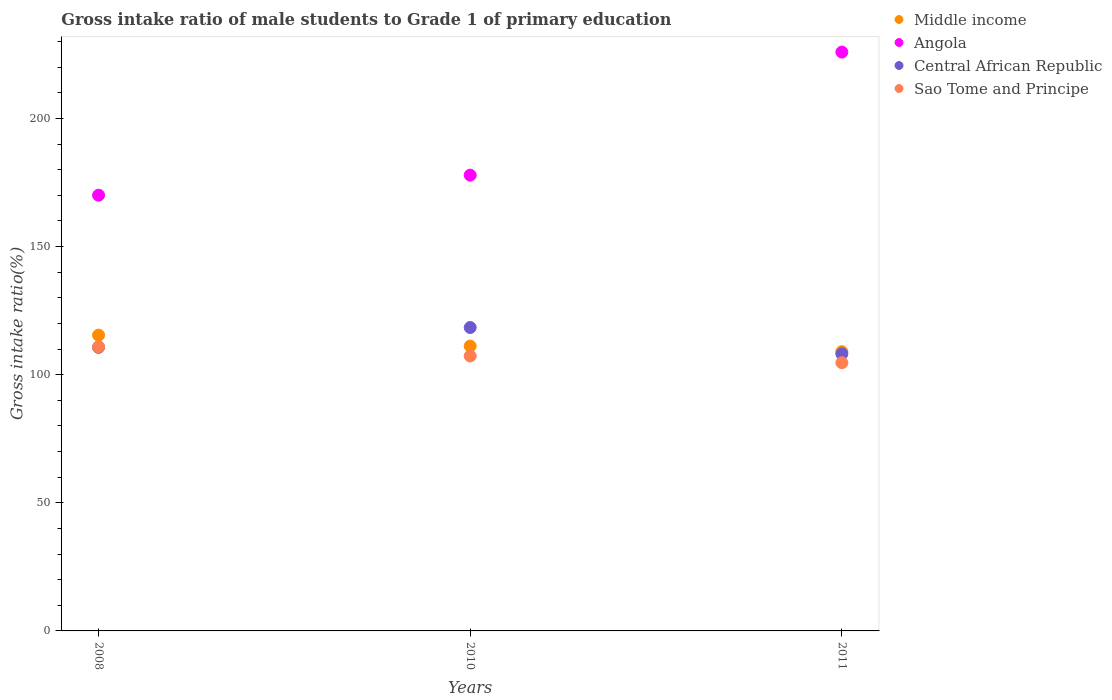How many different coloured dotlines are there?
Your answer should be compact. 4. What is the gross intake ratio in Angola in 2008?
Make the answer very short. 170.04. Across all years, what is the maximum gross intake ratio in Central African Republic?
Ensure brevity in your answer.  118.4. Across all years, what is the minimum gross intake ratio in Angola?
Your answer should be compact. 170.04. In which year was the gross intake ratio in Angola maximum?
Keep it short and to the point. 2011. In which year was the gross intake ratio in Central African Republic minimum?
Ensure brevity in your answer.  2011. What is the total gross intake ratio in Central African Republic in the graph?
Make the answer very short. 337.19. What is the difference between the gross intake ratio in Angola in 2010 and that in 2011?
Provide a succinct answer. -48.03. What is the difference between the gross intake ratio in Angola in 2008 and the gross intake ratio in Central African Republic in 2010?
Make the answer very short. 51.64. What is the average gross intake ratio in Sao Tome and Principe per year?
Offer a very short reply. 107.62. In the year 2011, what is the difference between the gross intake ratio in Middle income and gross intake ratio in Angola?
Provide a short and direct response. -116.92. What is the ratio of the gross intake ratio in Angola in 2008 to that in 2010?
Your answer should be very brief. 0.96. What is the difference between the highest and the second highest gross intake ratio in Middle income?
Offer a very short reply. 4.25. What is the difference between the highest and the lowest gross intake ratio in Central African Republic?
Offer a terse response. 10.28. In how many years, is the gross intake ratio in Angola greater than the average gross intake ratio in Angola taken over all years?
Make the answer very short. 1. Is the sum of the gross intake ratio in Sao Tome and Principe in 2008 and 2011 greater than the maximum gross intake ratio in Central African Republic across all years?
Ensure brevity in your answer.  Yes. Is it the case that in every year, the sum of the gross intake ratio in Sao Tome and Principe and gross intake ratio in Middle income  is greater than the gross intake ratio in Angola?
Make the answer very short. No. Does the gross intake ratio in Middle income monotonically increase over the years?
Your answer should be compact. No. Is the gross intake ratio in Central African Republic strictly less than the gross intake ratio in Sao Tome and Principe over the years?
Your response must be concise. No. How many dotlines are there?
Ensure brevity in your answer.  4. Does the graph contain grids?
Keep it short and to the point. No. Where does the legend appear in the graph?
Your answer should be very brief. Top right. How many legend labels are there?
Provide a succinct answer. 4. How are the legend labels stacked?
Provide a short and direct response. Vertical. What is the title of the graph?
Offer a terse response. Gross intake ratio of male students to Grade 1 of primary education. What is the label or title of the X-axis?
Your answer should be very brief. Years. What is the label or title of the Y-axis?
Provide a short and direct response. Gross intake ratio(%). What is the Gross intake ratio(%) of Middle income in 2008?
Offer a terse response. 115.42. What is the Gross intake ratio(%) of Angola in 2008?
Provide a succinct answer. 170.04. What is the Gross intake ratio(%) of Central African Republic in 2008?
Your answer should be compact. 110.66. What is the Gross intake ratio(%) in Sao Tome and Principe in 2008?
Give a very brief answer. 110.88. What is the Gross intake ratio(%) of Middle income in 2010?
Give a very brief answer. 111.17. What is the Gross intake ratio(%) in Angola in 2010?
Make the answer very short. 177.86. What is the Gross intake ratio(%) in Central African Republic in 2010?
Your response must be concise. 118.4. What is the Gross intake ratio(%) in Sao Tome and Principe in 2010?
Your answer should be very brief. 107.3. What is the Gross intake ratio(%) in Middle income in 2011?
Your answer should be compact. 108.97. What is the Gross intake ratio(%) of Angola in 2011?
Provide a succinct answer. 225.89. What is the Gross intake ratio(%) of Central African Republic in 2011?
Provide a short and direct response. 108.13. What is the Gross intake ratio(%) in Sao Tome and Principe in 2011?
Your response must be concise. 104.69. Across all years, what is the maximum Gross intake ratio(%) in Middle income?
Provide a short and direct response. 115.42. Across all years, what is the maximum Gross intake ratio(%) in Angola?
Keep it short and to the point. 225.89. Across all years, what is the maximum Gross intake ratio(%) in Central African Republic?
Make the answer very short. 118.4. Across all years, what is the maximum Gross intake ratio(%) of Sao Tome and Principe?
Offer a terse response. 110.88. Across all years, what is the minimum Gross intake ratio(%) of Middle income?
Provide a short and direct response. 108.97. Across all years, what is the minimum Gross intake ratio(%) of Angola?
Keep it short and to the point. 170.04. Across all years, what is the minimum Gross intake ratio(%) in Central African Republic?
Give a very brief answer. 108.13. Across all years, what is the minimum Gross intake ratio(%) of Sao Tome and Principe?
Offer a very short reply. 104.69. What is the total Gross intake ratio(%) of Middle income in the graph?
Make the answer very short. 335.57. What is the total Gross intake ratio(%) in Angola in the graph?
Your answer should be very brief. 573.79. What is the total Gross intake ratio(%) of Central African Republic in the graph?
Make the answer very short. 337.19. What is the total Gross intake ratio(%) of Sao Tome and Principe in the graph?
Make the answer very short. 322.87. What is the difference between the Gross intake ratio(%) of Middle income in 2008 and that in 2010?
Offer a very short reply. 4.25. What is the difference between the Gross intake ratio(%) in Angola in 2008 and that in 2010?
Your answer should be compact. -7.82. What is the difference between the Gross intake ratio(%) of Central African Republic in 2008 and that in 2010?
Offer a very short reply. -7.74. What is the difference between the Gross intake ratio(%) of Sao Tome and Principe in 2008 and that in 2010?
Ensure brevity in your answer.  3.59. What is the difference between the Gross intake ratio(%) of Middle income in 2008 and that in 2011?
Provide a succinct answer. 6.45. What is the difference between the Gross intake ratio(%) of Angola in 2008 and that in 2011?
Make the answer very short. -55.85. What is the difference between the Gross intake ratio(%) in Central African Republic in 2008 and that in 2011?
Offer a terse response. 2.54. What is the difference between the Gross intake ratio(%) of Sao Tome and Principe in 2008 and that in 2011?
Keep it short and to the point. 6.2. What is the difference between the Gross intake ratio(%) of Middle income in 2010 and that in 2011?
Provide a succinct answer. 2.2. What is the difference between the Gross intake ratio(%) in Angola in 2010 and that in 2011?
Keep it short and to the point. -48.03. What is the difference between the Gross intake ratio(%) of Central African Republic in 2010 and that in 2011?
Keep it short and to the point. 10.28. What is the difference between the Gross intake ratio(%) in Sao Tome and Principe in 2010 and that in 2011?
Keep it short and to the point. 2.61. What is the difference between the Gross intake ratio(%) of Middle income in 2008 and the Gross intake ratio(%) of Angola in 2010?
Provide a short and direct response. -62.44. What is the difference between the Gross intake ratio(%) in Middle income in 2008 and the Gross intake ratio(%) in Central African Republic in 2010?
Offer a terse response. -2.98. What is the difference between the Gross intake ratio(%) in Middle income in 2008 and the Gross intake ratio(%) in Sao Tome and Principe in 2010?
Your response must be concise. 8.12. What is the difference between the Gross intake ratio(%) in Angola in 2008 and the Gross intake ratio(%) in Central African Republic in 2010?
Offer a very short reply. 51.64. What is the difference between the Gross intake ratio(%) of Angola in 2008 and the Gross intake ratio(%) of Sao Tome and Principe in 2010?
Your answer should be compact. 62.74. What is the difference between the Gross intake ratio(%) of Central African Republic in 2008 and the Gross intake ratio(%) of Sao Tome and Principe in 2010?
Provide a short and direct response. 3.37. What is the difference between the Gross intake ratio(%) of Middle income in 2008 and the Gross intake ratio(%) of Angola in 2011?
Provide a succinct answer. -110.47. What is the difference between the Gross intake ratio(%) in Middle income in 2008 and the Gross intake ratio(%) in Central African Republic in 2011?
Make the answer very short. 7.29. What is the difference between the Gross intake ratio(%) of Middle income in 2008 and the Gross intake ratio(%) of Sao Tome and Principe in 2011?
Your answer should be compact. 10.74. What is the difference between the Gross intake ratio(%) of Angola in 2008 and the Gross intake ratio(%) of Central African Republic in 2011?
Give a very brief answer. 61.92. What is the difference between the Gross intake ratio(%) of Angola in 2008 and the Gross intake ratio(%) of Sao Tome and Principe in 2011?
Your answer should be compact. 65.36. What is the difference between the Gross intake ratio(%) of Central African Republic in 2008 and the Gross intake ratio(%) of Sao Tome and Principe in 2011?
Keep it short and to the point. 5.98. What is the difference between the Gross intake ratio(%) in Middle income in 2010 and the Gross intake ratio(%) in Angola in 2011?
Give a very brief answer. -114.72. What is the difference between the Gross intake ratio(%) of Middle income in 2010 and the Gross intake ratio(%) of Central African Republic in 2011?
Give a very brief answer. 3.05. What is the difference between the Gross intake ratio(%) of Middle income in 2010 and the Gross intake ratio(%) of Sao Tome and Principe in 2011?
Make the answer very short. 6.49. What is the difference between the Gross intake ratio(%) in Angola in 2010 and the Gross intake ratio(%) in Central African Republic in 2011?
Provide a succinct answer. 69.74. What is the difference between the Gross intake ratio(%) of Angola in 2010 and the Gross intake ratio(%) of Sao Tome and Principe in 2011?
Give a very brief answer. 73.18. What is the difference between the Gross intake ratio(%) in Central African Republic in 2010 and the Gross intake ratio(%) in Sao Tome and Principe in 2011?
Ensure brevity in your answer.  13.72. What is the average Gross intake ratio(%) of Middle income per year?
Your response must be concise. 111.86. What is the average Gross intake ratio(%) in Angola per year?
Your answer should be compact. 191.26. What is the average Gross intake ratio(%) in Central African Republic per year?
Provide a short and direct response. 112.4. What is the average Gross intake ratio(%) in Sao Tome and Principe per year?
Make the answer very short. 107.62. In the year 2008, what is the difference between the Gross intake ratio(%) of Middle income and Gross intake ratio(%) of Angola?
Make the answer very short. -54.62. In the year 2008, what is the difference between the Gross intake ratio(%) in Middle income and Gross intake ratio(%) in Central African Republic?
Ensure brevity in your answer.  4.76. In the year 2008, what is the difference between the Gross intake ratio(%) in Middle income and Gross intake ratio(%) in Sao Tome and Principe?
Your answer should be compact. 4.54. In the year 2008, what is the difference between the Gross intake ratio(%) in Angola and Gross intake ratio(%) in Central African Republic?
Keep it short and to the point. 59.38. In the year 2008, what is the difference between the Gross intake ratio(%) of Angola and Gross intake ratio(%) of Sao Tome and Principe?
Offer a terse response. 59.16. In the year 2008, what is the difference between the Gross intake ratio(%) of Central African Republic and Gross intake ratio(%) of Sao Tome and Principe?
Make the answer very short. -0.22. In the year 2010, what is the difference between the Gross intake ratio(%) of Middle income and Gross intake ratio(%) of Angola?
Provide a succinct answer. -66.69. In the year 2010, what is the difference between the Gross intake ratio(%) in Middle income and Gross intake ratio(%) in Central African Republic?
Offer a very short reply. -7.23. In the year 2010, what is the difference between the Gross intake ratio(%) of Middle income and Gross intake ratio(%) of Sao Tome and Principe?
Your response must be concise. 3.87. In the year 2010, what is the difference between the Gross intake ratio(%) of Angola and Gross intake ratio(%) of Central African Republic?
Provide a short and direct response. 59.46. In the year 2010, what is the difference between the Gross intake ratio(%) in Angola and Gross intake ratio(%) in Sao Tome and Principe?
Your response must be concise. 70.56. In the year 2010, what is the difference between the Gross intake ratio(%) of Central African Republic and Gross intake ratio(%) of Sao Tome and Principe?
Offer a terse response. 11.1. In the year 2011, what is the difference between the Gross intake ratio(%) in Middle income and Gross intake ratio(%) in Angola?
Your response must be concise. -116.92. In the year 2011, what is the difference between the Gross intake ratio(%) in Middle income and Gross intake ratio(%) in Central African Republic?
Ensure brevity in your answer.  0.84. In the year 2011, what is the difference between the Gross intake ratio(%) of Middle income and Gross intake ratio(%) of Sao Tome and Principe?
Make the answer very short. 4.29. In the year 2011, what is the difference between the Gross intake ratio(%) in Angola and Gross intake ratio(%) in Central African Republic?
Provide a succinct answer. 117.76. In the year 2011, what is the difference between the Gross intake ratio(%) of Angola and Gross intake ratio(%) of Sao Tome and Principe?
Give a very brief answer. 121.2. In the year 2011, what is the difference between the Gross intake ratio(%) of Central African Republic and Gross intake ratio(%) of Sao Tome and Principe?
Provide a succinct answer. 3.44. What is the ratio of the Gross intake ratio(%) in Middle income in 2008 to that in 2010?
Provide a succinct answer. 1.04. What is the ratio of the Gross intake ratio(%) in Angola in 2008 to that in 2010?
Provide a succinct answer. 0.96. What is the ratio of the Gross intake ratio(%) in Central African Republic in 2008 to that in 2010?
Your answer should be very brief. 0.93. What is the ratio of the Gross intake ratio(%) of Sao Tome and Principe in 2008 to that in 2010?
Provide a short and direct response. 1.03. What is the ratio of the Gross intake ratio(%) of Middle income in 2008 to that in 2011?
Make the answer very short. 1.06. What is the ratio of the Gross intake ratio(%) in Angola in 2008 to that in 2011?
Make the answer very short. 0.75. What is the ratio of the Gross intake ratio(%) in Central African Republic in 2008 to that in 2011?
Your answer should be compact. 1.02. What is the ratio of the Gross intake ratio(%) of Sao Tome and Principe in 2008 to that in 2011?
Ensure brevity in your answer.  1.06. What is the ratio of the Gross intake ratio(%) in Middle income in 2010 to that in 2011?
Offer a terse response. 1.02. What is the ratio of the Gross intake ratio(%) in Angola in 2010 to that in 2011?
Give a very brief answer. 0.79. What is the ratio of the Gross intake ratio(%) of Central African Republic in 2010 to that in 2011?
Provide a succinct answer. 1.09. What is the ratio of the Gross intake ratio(%) of Sao Tome and Principe in 2010 to that in 2011?
Keep it short and to the point. 1.02. What is the difference between the highest and the second highest Gross intake ratio(%) of Middle income?
Provide a succinct answer. 4.25. What is the difference between the highest and the second highest Gross intake ratio(%) of Angola?
Offer a very short reply. 48.03. What is the difference between the highest and the second highest Gross intake ratio(%) in Central African Republic?
Provide a succinct answer. 7.74. What is the difference between the highest and the second highest Gross intake ratio(%) of Sao Tome and Principe?
Keep it short and to the point. 3.59. What is the difference between the highest and the lowest Gross intake ratio(%) of Middle income?
Provide a succinct answer. 6.45. What is the difference between the highest and the lowest Gross intake ratio(%) in Angola?
Keep it short and to the point. 55.85. What is the difference between the highest and the lowest Gross intake ratio(%) in Central African Republic?
Your response must be concise. 10.28. What is the difference between the highest and the lowest Gross intake ratio(%) of Sao Tome and Principe?
Provide a short and direct response. 6.2. 